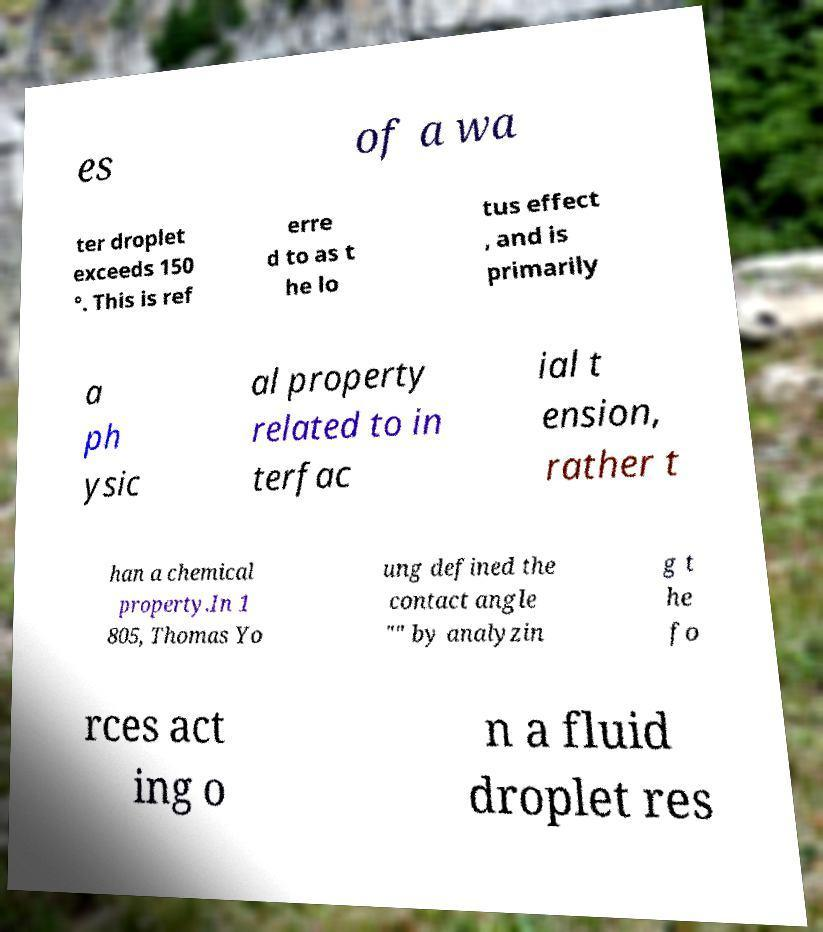Can you read and provide the text displayed in the image?This photo seems to have some interesting text. Can you extract and type it out for me? es of a wa ter droplet exceeds 150 °. This is ref erre d to as t he lo tus effect , and is primarily a ph ysic al property related to in terfac ial t ension, rather t han a chemical property.In 1 805, Thomas Yo ung defined the contact angle "" by analyzin g t he fo rces act ing o n a fluid droplet res 